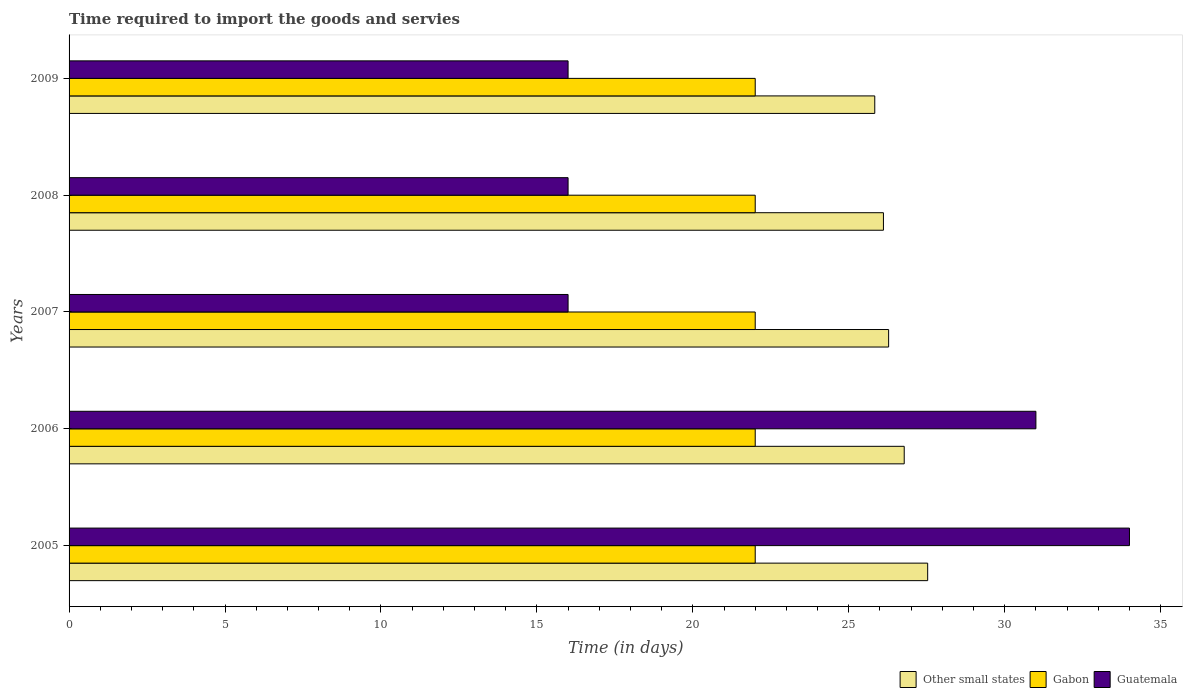Are the number of bars on each tick of the Y-axis equal?
Your response must be concise. Yes. How many bars are there on the 1st tick from the top?
Your answer should be very brief. 3. In how many cases, is the number of bars for a given year not equal to the number of legend labels?
Keep it short and to the point. 0. What is the number of days required to import the goods and services in Gabon in 2005?
Provide a succinct answer. 22. Across all years, what is the maximum number of days required to import the goods and services in Other small states?
Your answer should be very brief. 27.53. Across all years, what is the minimum number of days required to import the goods and services in Guatemala?
Offer a terse response. 16. What is the total number of days required to import the goods and services in Gabon in the graph?
Your answer should be compact. 110. What is the difference between the number of days required to import the goods and services in Guatemala in 2006 and that in 2007?
Your response must be concise. 15. What is the difference between the number of days required to import the goods and services in Guatemala in 2006 and the number of days required to import the goods and services in Other small states in 2008?
Provide a succinct answer. 4.89. In the year 2007, what is the difference between the number of days required to import the goods and services in Gabon and number of days required to import the goods and services in Other small states?
Your answer should be compact. -4.28. In how many years, is the number of days required to import the goods and services in Gabon greater than 28 days?
Make the answer very short. 0. What is the ratio of the number of days required to import the goods and services in Other small states in 2005 to that in 2007?
Provide a succinct answer. 1.05. Is the difference between the number of days required to import the goods and services in Gabon in 2008 and 2009 greater than the difference between the number of days required to import the goods and services in Other small states in 2008 and 2009?
Provide a succinct answer. No. What is the difference between the highest and the second highest number of days required to import the goods and services in Other small states?
Keep it short and to the point. 0.75. What is the difference between the highest and the lowest number of days required to import the goods and services in Guatemala?
Make the answer very short. 18. In how many years, is the number of days required to import the goods and services in Guatemala greater than the average number of days required to import the goods and services in Guatemala taken over all years?
Ensure brevity in your answer.  2. Is the sum of the number of days required to import the goods and services in Other small states in 2006 and 2007 greater than the maximum number of days required to import the goods and services in Guatemala across all years?
Provide a short and direct response. Yes. What does the 2nd bar from the top in 2005 represents?
Offer a very short reply. Gabon. What does the 1st bar from the bottom in 2006 represents?
Give a very brief answer. Other small states. Is it the case that in every year, the sum of the number of days required to import the goods and services in Guatemala and number of days required to import the goods and services in Gabon is greater than the number of days required to import the goods and services in Other small states?
Give a very brief answer. Yes. How many bars are there?
Offer a terse response. 15. Does the graph contain grids?
Your answer should be very brief. No. How are the legend labels stacked?
Keep it short and to the point. Horizontal. What is the title of the graph?
Offer a terse response. Time required to import the goods and servies. Does "Least developed countries" appear as one of the legend labels in the graph?
Your response must be concise. No. What is the label or title of the X-axis?
Make the answer very short. Time (in days). What is the label or title of the Y-axis?
Ensure brevity in your answer.  Years. What is the Time (in days) of Other small states in 2005?
Ensure brevity in your answer.  27.53. What is the Time (in days) of Gabon in 2005?
Give a very brief answer. 22. What is the Time (in days) of Other small states in 2006?
Make the answer very short. 26.78. What is the Time (in days) of Other small states in 2007?
Keep it short and to the point. 26.28. What is the Time (in days) in Gabon in 2007?
Make the answer very short. 22. What is the Time (in days) of Other small states in 2008?
Make the answer very short. 26.11. What is the Time (in days) of Gabon in 2008?
Your response must be concise. 22. What is the Time (in days) of Other small states in 2009?
Offer a terse response. 25.83. What is the Time (in days) of Gabon in 2009?
Your answer should be very brief. 22. Across all years, what is the maximum Time (in days) of Other small states?
Give a very brief answer. 27.53. Across all years, what is the maximum Time (in days) of Gabon?
Keep it short and to the point. 22. Across all years, what is the minimum Time (in days) of Other small states?
Ensure brevity in your answer.  25.83. What is the total Time (in days) in Other small states in the graph?
Ensure brevity in your answer.  132.53. What is the total Time (in days) in Gabon in the graph?
Make the answer very short. 110. What is the total Time (in days) in Guatemala in the graph?
Give a very brief answer. 113. What is the difference between the Time (in days) of Other small states in 2005 and that in 2006?
Provide a short and direct response. 0.75. What is the difference between the Time (in days) in Gabon in 2005 and that in 2006?
Ensure brevity in your answer.  0. What is the difference between the Time (in days) of Guatemala in 2005 and that in 2006?
Give a very brief answer. 3. What is the difference between the Time (in days) of Other small states in 2005 and that in 2007?
Offer a very short reply. 1.25. What is the difference between the Time (in days) in Gabon in 2005 and that in 2007?
Ensure brevity in your answer.  0. What is the difference between the Time (in days) of Guatemala in 2005 and that in 2007?
Give a very brief answer. 18. What is the difference between the Time (in days) in Other small states in 2005 and that in 2008?
Make the answer very short. 1.42. What is the difference between the Time (in days) in Gabon in 2005 and that in 2008?
Offer a very short reply. 0. What is the difference between the Time (in days) in Guatemala in 2005 and that in 2008?
Give a very brief answer. 18. What is the difference between the Time (in days) in Other small states in 2005 and that in 2009?
Offer a terse response. 1.7. What is the difference between the Time (in days) in Other small states in 2006 and that in 2007?
Provide a short and direct response. 0.5. What is the difference between the Time (in days) of Guatemala in 2006 and that in 2007?
Provide a succinct answer. 15. What is the difference between the Time (in days) in Other small states in 2006 and that in 2008?
Keep it short and to the point. 0.67. What is the difference between the Time (in days) in Gabon in 2006 and that in 2008?
Provide a succinct answer. 0. What is the difference between the Time (in days) of Guatemala in 2006 and that in 2008?
Provide a short and direct response. 15. What is the difference between the Time (in days) of Gabon in 2006 and that in 2009?
Ensure brevity in your answer.  0. What is the difference between the Time (in days) of Guatemala in 2006 and that in 2009?
Offer a very short reply. 15. What is the difference between the Time (in days) of Other small states in 2007 and that in 2008?
Provide a succinct answer. 0.17. What is the difference between the Time (in days) in Gabon in 2007 and that in 2008?
Offer a terse response. 0. What is the difference between the Time (in days) of Other small states in 2007 and that in 2009?
Offer a terse response. 0.44. What is the difference between the Time (in days) in Guatemala in 2007 and that in 2009?
Offer a very short reply. 0. What is the difference between the Time (in days) of Other small states in 2008 and that in 2009?
Keep it short and to the point. 0.28. What is the difference between the Time (in days) in Gabon in 2008 and that in 2009?
Keep it short and to the point. 0. What is the difference between the Time (in days) in Guatemala in 2008 and that in 2009?
Offer a very short reply. 0. What is the difference between the Time (in days) in Other small states in 2005 and the Time (in days) in Gabon in 2006?
Offer a very short reply. 5.53. What is the difference between the Time (in days) of Other small states in 2005 and the Time (in days) of Guatemala in 2006?
Ensure brevity in your answer.  -3.47. What is the difference between the Time (in days) of Other small states in 2005 and the Time (in days) of Gabon in 2007?
Ensure brevity in your answer.  5.53. What is the difference between the Time (in days) of Other small states in 2005 and the Time (in days) of Guatemala in 2007?
Give a very brief answer. 11.53. What is the difference between the Time (in days) of Gabon in 2005 and the Time (in days) of Guatemala in 2007?
Make the answer very short. 6. What is the difference between the Time (in days) of Other small states in 2005 and the Time (in days) of Gabon in 2008?
Offer a very short reply. 5.53. What is the difference between the Time (in days) in Other small states in 2005 and the Time (in days) in Guatemala in 2008?
Ensure brevity in your answer.  11.53. What is the difference between the Time (in days) in Gabon in 2005 and the Time (in days) in Guatemala in 2008?
Provide a succinct answer. 6. What is the difference between the Time (in days) of Other small states in 2005 and the Time (in days) of Gabon in 2009?
Provide a succinct answer. 5.53. What is the difference between the Time (in days) in Other small states in 2005 and the Time (in days) in Guatemala in 2009?
Ensure brevity in your answer.  11.53. What is the difference between the Time (in days) in Gabon in 2005 and the Time (in days) in Guatemala in 2009?
Keep it short and to the point. 6. What is the difference between the Time (in days) of Other small states in 2006 and the Time (in days) of Gabon in 2007?
Your answer should be compact. 4.78. What is the difference between the Time (in days) in Other small states in 2006 and the Time (in days) in Guatemala in 2007?
Your answer should be very brief. 10.78. What is the difference between the Time (in days) of Other small states in 2006 and the Time (in days) of Gabon in 2008?
Your response must be concise. 4.78. What is the difference between the Time (in days) in Other small states in 2006 and the Time (in days) in Guatemala in 2008?
Provide a succinct answer. 10.78. What is the difference between the Time (in days) in Other small states in 2006 and the Time (in days) in Gabon in 2009?
Offer a terse response. 4.78. What is the difference between the Time (in days) of Other small states in 2006 and the Time (in days) of Guatemala in 2009?
Ensure brevity in your answer.  10.78. What is the difference between the Time (in days) in Gabon in 2006 and the Time (in days) in Guatemala in 2009?
Give a very brief answer. 6. What is the difference between the Time (in days) in Other small states in 2007 and the Time (in days) in Gabon in 2008?
Your answer should be very brief. 4.28. What is the difference between the Time (in days) of Other small states in 2007 and the Time (in days) of Guatemala in 2008?
Provide a short and direct response. 10.28. What is the difference between the Time (in days) of Gabon in 2007 and the Time (in days) of Guatemala in 2008?
Give a very brief answer. 6. What is the difference between the Time (in days) of Other small states in 2007 and the Time (in days) of Gabon in 2009?
Provide a short and direct response. 4.28. What is the difference between the Time (in days) of Other small states in 2007 and the Time (in days) of Guatemala in 2009?
Ensure brevity in your answer.  10.28. What is the difference between the Time (in days) of Gabon in 2007 and the Time (in days) of Guatemala in 2009?
Keep it short and to the point. 6. What is the difference between the Time (in days) in Other small states in 2008 and the Time (in days) in Gabon in 2009?
Your answer should be compact. 4.11. What is the difference between the Time (in days) of Other small states in 2008 and the Time (in days) of Guatemala in 2009?
Offer a terse response. 10.11. What is the average Time (in days) in Other small states per year?
Offer a terse response. 26.51. What is the average Time (in days) of Gabon per year?
Ensure brevity in your answer.  22. What is the average Time (in days) of Guatemala per year?
Make the answer very short. 22.6. In the year 2005, what is the difference between the Time (in days) of Other small states and Time (in days) of Gabon?
Keep it short and to the point. 5.53. In the year 2005, what is the difference between the Time (in days) in Other small states and Time (in days) in Guatemala?
Make the answer very short. -6.47. In the year 2005, what is the difference between the Time (in days) of Gabon and Time (in days) of Guatemala?
Provide a short and direct response. -12. In the year 2006, what is the difference between the Time (in days) in Other small states and Time (in days) in Gabon?
Keep it short and to the point. 4.78. In the year 2006, what is the difference between the Time (in days) in Other small states and Time (in days) in Guatemala?
Provide a short and direct response. -4.22. In the year 2006, what is the difference between the Time (in days) in Gabon and Time (in days) in Guatemala?
Offer a terse response. -9. In the year 2007, what is the difference between the Time (in days) in Other small states and Time (in days) in Gabon?
Make the answer very short. 4.28. In the year 2007, what is the difference between the Time (in days) of Other small states and Time (in days) of Guatemala?
Ensure brevity in your answer.  10.28. In the year 2007, what is the difference between the Time (in days) of Gabon and Time (in days) of Guatemala?
Offer a terse response. 6. In the year 2008, what is the difference between the Time (in days) in Other small states and Time (in days) in Gabon?
Give a very brief answer. 4.11. In the year 2008, what is the difference between the Time (in days) of Other small states and Time (in days) of Guatemala?
Offer a very short reply. 10.11. In the year 2008, what is the difference between the Time (in days) of Gabon and Time (in days) of Guatemala?
Give a very brief answer. 6. In the year 2009, what is the difference between the Time (in days) of Other small states and Time (in days) of Gabon?
Offer a very short reply. 3.83. In the year 2009, what is the difference between the Time (in days) of Other small states and Time (in days) of Guatemala?
Your response must be concise. 9.83. In the year 2009, what is the difference between the Time (in days) in Gabon and Time (in days) in Guatemala?
Ensure brevity in your answer.  6. What is the ratio of the Time (in days) in Other small states in 2005 to that in 2006?
Provide a succinct answer. 1.03. What is the ratio of the Time (in days) of Guatemala in 2005 to that in 2006?
Make the answer very short. 1.1. What is the ratio of the Time (in days) in Other small states in 2005 to that in 2007?
Make the answer very short. 1.05. What is the ratio of the Time (in days) of Guatemala in 2005 to that in 2007?
Offer a very short reply. 2.12. What is the ratio of the Time (in days) in Other small states in 2005 to that in 2008?
Ensure brevity in your answer.  1.05. What is the ratio of the Time (in days) in Gabon in 2005 to that in 2008?
Give a very brief answer. 1. What is the ratio of the Time (in days) of Guatemala in 2005 to that in 2008?
Your answer should be compact. 2.12. What is the ratio of the Time (in days) in Other small states in 2005 to that in 2009?
Provide a short and direct response. 1.07. What is the ratio of the Time (in days) of Guatemala in 2005 to that in 2009?
Offer a terse response. 2.12. What is the ratio of the Time (in days) in Other small states in 2006 to that in 2007?
Provide a succinct answer. 1.02. What is the ratio of the Time (in days) of Gabon in 2006 to that in 2007?
Your answer should be very brief. 1. What is the ratio of the Time (in days) of Guatemala in 2006 to that in 2007?
Provide a short and direct response. 1.94. What is the ratio of the Time (in days) in Other small states in 2006 to that in 2008?
Give a very brief answer. 1.03. What is the ratio of the Time (in days) of Guatemala in 2006 to that in 2008?
Give a very brief answer. 1.94. What is the ratio of the Time (in days) in Other small states in 2006 to that in 2009?
Offer a terse response. 1.04. What is the ratio of the Time (in days) of Gabon in 2006 to that in 2009?
Keep it short and to the point. 1. What is the ratio of the Time (in days) of Guatemala in 2006 to that in 2009?
Give a very brief answer. 1.94. What is the ratio of the Time (in days) in Other small states in 2007 to that in 2008?
Keep it short and to the point. 1.01. What is the ratio of the Time (in days) of Gabon in 2007 to that in 2008?
Offer a terse response. 1. What is the ratio of the Time (in days) of Guatemala in 2007 to that in 2008?
Your answer should be very brief. 1. What is the ratio of the Time (in days) in Other small states in 2007 to that in 2009?
Make the answer very short. 1.02. What is the ratio of the Time (in days) in Gabon in 2007 to that in 2009?
Offer a terse response. 1. What is the ratio of the Time (in days) of Guatemala in 2007 to that in 2009?
Your response must be concise. 1. What is the ratio of the Time (in days) in Other small states in 2008 to that in 2009?
Provide a short and direct response. 1.01. What is the ratio of the Time (in days) of Gabon in 2008 to that in 2009?
Give a very brief answer. 1. What is the ratio of the Time (in days) in Guatemala in 2008 to that in 2009?
Your response must be concise. 1. What is the difference between the highest and the second highest Time (in days) in Other small states?
Your response must be concise. 0.75. What is the difference between the highest and the lowest Time (in days) of Other small states?
Provide a succinct answer. 1.7. 